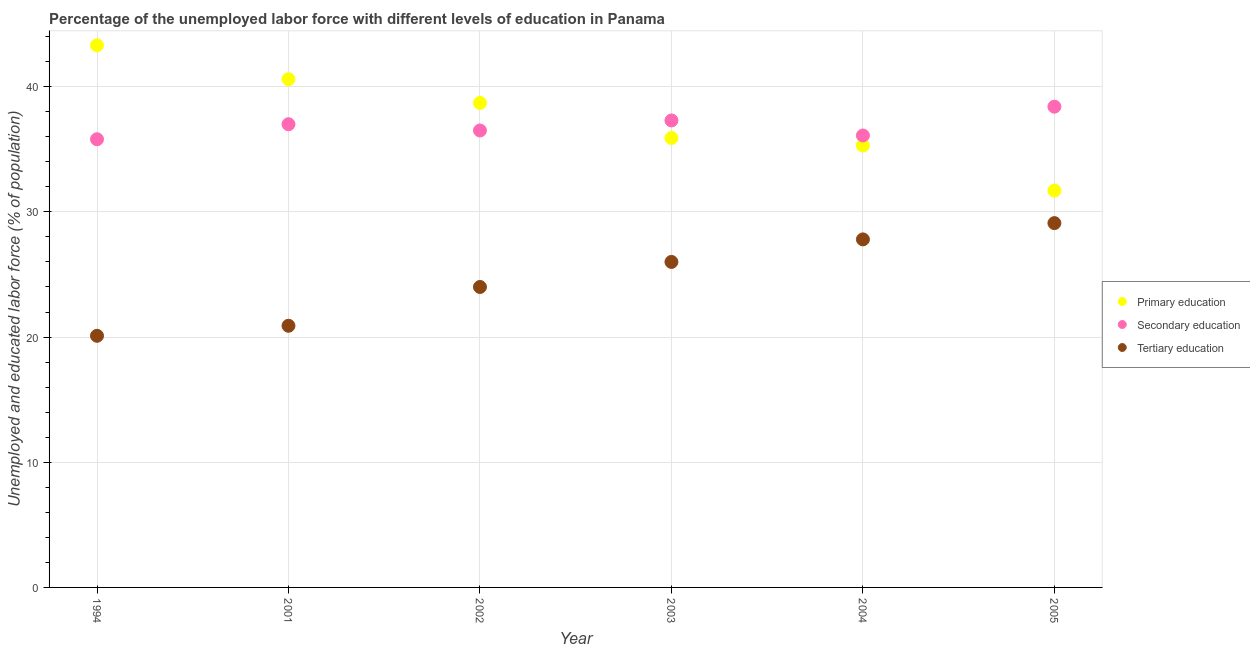How many different coloured dotlines are there?
Your answer should be very brief. 3. What is the percentage of labor force who received secondary education in 2003?
Give a very brief answer. 37.3. Across all years, what is the maximum percentage of labor force who received primary education?
Give a very brief answer. 43.3. Across all years, what is the minimum percentage of labor force who received primary education?
Provide a succinct answer. 31.7. What is the total percentage of labor force who received secondary education in the graph?
Provide a succinct answer. 221.1. What is the difference between the percentage of labor force who received primary education in 2003 and that in 2004?
Give a very brief answer. 0.6. What is the difference between the percentage of labor force who received tertiary education in 2003 and the percentage of labor force who received secondary education in 2005?
Give a very brief answer. -12.4. What is the average percentage of labor force who received primary education per year?
Ensure brevity in your answer.  37.58. In the year 2005, what is the difference between the percentage of labor force who received tertiary education and percentage of labor force who received primary education?
Keep it short and to the point. -2.6. In how many years, is the percentage of labor force who received primary education greater than 42 %?
Give a very brief answer. 1. What is the ratio of the percentage of labor force who received secondary education in 2001 to that in 2005?
Offer a very short reply. 0.96. Is the difference between the percentage of labor force who received primary education in 1994 and 2003 greater than the difference between the percentage of labor force who received tertiary education in 1994 and 2003?
Your answer should be very brief. Yes. What is the difference between the highest and the second highest percentage of labor force who received primary education?
Make the answer very short. 2.7. What is the difference between the highest and the lowest percentage of labor force who received primary education?
Provide a short and direct response. 11.6. In how many years, is the percentage of labor force who received primary education greater than the average percentage of labor force who received primary education taken over all years?
Ensure brevity in your answer.  3. Is it the case that in every year, the sum of the percentage of labor force who received primary education and percentage of labor force who received secondary education is greater than the percentage of labor force who received tertiary education?
Offer a very short reply. Yes. How many dotlines are there?
Your answer should be compact. 3. How many years are there in the graph?
Offer a very short reply. 6. What is the difference between two consecutive major ticks on the Y-axis?
Offer a very short reply. 10. Does the graph contain any zero values?
Make the answer very short. No. Does the graph contain grids?
Give a very brief answer. Yes. Where does the legend appear in the graph?
Provide a short and direct response. Center right. How are the legend labels stacked?
Offer a terse response. Vertical. What is the title of the graph?
Provide a succinct answer. Percentage of the unemployed labor force with different levels of education in Panama. What is the label or title of the X-axis?
Your answer should be compact. Year. What is the label or title of the Y-axis?
Your answer should be compact. Unemployed and educated labor force (% of population). What is the Unemployed and educated labor force (% of population) of Primary education in 1994?
Ensure brevity in your answer.  43.3. What is the Unemployed and educated labor force (% of population) of Secondary education in 1994?
Provide a succinct answer. 35.8. What is the Unemployed and educated labor force (% of population) of Tertiary education in 1994?
Your answer should be very brief. 20.1. What is the Unemployed and educated labor force (% of population) of Primary education in 2001?
Offer a very short reply. 40.6. What is the Unemployed and educated labor force (% of population) of Secondary education in 2001?
Offer a terse response. 37. What is the Unemployed and educated labor force (% of population) in Tertiary education in 2001?
Provide a succinct answer. 20.9. What is the Unemployed and educated labor force (% of population) of Primary education in 2002?
Make the answer very short. 38.7. What is the Unemployed and educated labor force (% of population) in Secondary education in 2002?
Offer a terse response. 36.5. What is the Unemployed and educated labor force (% of population) in Primary education in 2003?
Make the answer very short. 35.9. What is the Unemployed and educated labor force (% of population) of Secondary education in 2003?
Your answer should be compact. 37.3. What is the Unemployed and educated labor force (% of population) in Primary education in 2004?
Provide a short and direct response. 35.3. What is the Unemployed and educated labor force (% of population) in Secondary education in 2004?
Provide a short and direct response. 36.1. What is the Unemployed and educated labor force (% of population) of Tertiary education in 2004?
Provide a short and direct response. 27.8. What is the Unemployed and educated labor force (% of population) in Primary education in 2005?
Offer a very short reply. 31.7. What is the Unemployed and educated labor force (% of population) of Secondary education in 2005?
Ensure brevity in your answer.  38.4. What is the Unemployed and educated labor force (% of population) in Tertiary education in 2005?
Your response must be concise. 29.1. Across all years, what is the maximum Unemployed and educated labor force (% of population) of Primary education?
Provide a short and direct response. 43.3. Across all years, what is the maximum Unemployed and educated labor force (% of population) in Secondary education?
Ensure brevity in your answer.  38.4. Across all years, what is the maximum Unemployed and educated labor force (% of population) in Tertiary education?
Your response must be concise. 29.1. Across all years, what is the minimum Unemployed and educated labor force (% of population) in Primary education?
Offer a very short reply. 31.7. Across all years, what is the minimum Unemployed and educated labor force (% of population) of Secondary education?
Provide a short and direct response. 35.8. Across all years, what is the minimum Unemployed and educated labor force (% of population) in Tertiary education?
Ensure brevity in your answer.  20.1. What is the total Unemployed and educated labor force (% of population) of Primary education in the graph?
Your answer should be compact. 225.5. What is the total Unemployed and educated labor force (% of population) in Secondary education in the graph?
Provide a succinct answer. 221.1. What is the total Unemployed and educated labor force (% of population) of Tertiary education in the graph?
Provide a short and direct response. 147.9. What is the difference between the Unemployed and educated labor force (% of population) of Primary education in 1994 and that in 2001?
Keep it short and to the point. 2.7. What is the difference between the Unemployed and educated labor force (% of population) in Secondary education in 1994 and that in 2001?
Your response must be concise. -1.2. What is the difference between the Unemployed and educated labor force (% of population) of Tertiary education in 1994 and that in 2001?
Your response must be concise. -0.8. What is the difference between the Unemployed and educated labor force (% of population) of Tertiary education in 1994 and that in 2002?
Your answer should be very brief. -3.9. What is the difference between the Unemployed and educated labor force (% of population) of Primary education in 1994 and that in 2004?
Provide a short and direct response. 8. What is the difference between the Unemployed and educated labor force (% of population) of Secondary education in 1994 and that in 2004?
Offer a terse response. -0.3. What is the difference between the Unemployed and educated labor force (% of population) in Tertiary education in 1994 and that in 2004?
Provide a succinct answer. -7.7. What is the difference between the Unemployed and educated labor force (% of population) of Primary education in 1994 and that in 2005?
Ensure brevity in your answer.  11.6. What is the difference between the Unemployed and educated labor force (% of population) in Secondary education in 2001 and that in 2002?
Keep it short and to the point. 0.5. What is the difference between the Unemployed and educated labor force (% of population) of Tertiary education in 2001 and that in 2002?
Offer a terse response. -3.1. What is the difference between the Unemployed and educated labor force (% of population) in Primary education in 2001 and that in 2003?
Keep it short and to the point. 4.7. What is the difference between the Unemployed and educated labor force (% of population) of Secondary education in 2001 and that in 2003?
Your response must be concise. -0.3. What is the difference between the Unemployed and educated labor force (% of population) of Secondary education in 2001 and that in 2004?
Keep it short and to the point. 0.9. What is the difference between the Unemployed and educated labor force (% of population) of Tertiary education in 2001 and that in 2004?
Provide a succinct answer. -6.9. What is the difference between the Unemployed and educated labor force (% of population) in Primary education in 2001 and that in 2005?
Ensure brevity in your answer.  8.9. What is the difference between the Unemployed and educated labor force (% of population) of Primary education in 2002 and that in 2003?
Provide a succinct answer. 2.8. What is the difference between the Unemployed and educated labor force (% of population) in Secondary education in 2002 and that in 2003?
Provide a succinct answer. -0.8. What is the difference between the Unemployed and educated labor force (% of population) of Tertiary education in 2002 and that in 2003?
Make the answer very short. -2. What is the difference between the Unemployed and educated labor force (% of population) of Primary education in 2002 and that in 2004?
Make the answer very short. 3.4. What is the difference between the Unemployed and educated labor force (% of population) in Secondary education in 2002 and that in 2004?
Your answer should be very brief. 0.4. What is the difference between the Unemployed and educated labor force (% of population) of Tertiary education in 2002 and that in 2004?
Give a very brief answer. -3.8. What is the difference between the Unemployed and educated labor force (% of population) in Primary education in 2002 and that in 2005?
Provide a short and direct response. 7. What is the difference between the Unemployed and educated labor force (% of population) in Primary education in 2003 and that in 2005?
Provide a succinct answer. 4.2. What is the difference between the Unemployed and educated labor force (% of population) of Tertiary education in 2003 and that in 2005?
Provide a short and direct response. -3.1. What is the difference between the Unemployed and educated labor force (% of population) in Primary education in 2004 and that in 2005?
Offer a terse response. 3.6. What is the difference between the Unemployed and educated labor force (% of population) in Secondary education in 2004 and that in 2005?
Make the answer very short. -2.3. What is the difference between the Unemployed and educated labor force (% of population) in Primary education in 1994 and the Unemployed and educated labor force (% of population) in Tertiary education in 2001?
Provide a succinct answer. 22.4. What is the difference between the Unemployed and educated labor force (% of population) in Primary education in 1994 and the Unemployed and educated labor force (% of population) in Tertiary education in 2002?
Ensure brevity in your answer.  19.3. What is the difference between the Unemployed and educated labor force (% of population) in Secondary education in 1994 and the Unemployed and educated labor force (% of population) in Tertiary education in 2002?
Provide a succinct answer. 11.8. What is the difference between the Unemployed and educated labor force (% of population) of Primary education in 1994 and the Unemployed and educated labor force (% of population) of Tertiary education in 2003?
Your response must be concise. 17.3. What is the difference between the Unemployed and educated labor force (% of population) of Primary education in 1994 and the Unemployed and educated labor force (% of population) of Tertiary education in 2004?
Provide a succinct answer. 15.5. What is the difference between the Unemployed and educated labor force (% of population) in Primary education in 1994 and the Unemployed and educated labor force (% of population) in Tertiary education in 2005?
Your answer should be very brief. 14.2. What is the difference between the Unemployed and educated labor force (% of population) in Secondary education in 2001 and the Unemployed and educated labor force (% of population) in Tertiary education in 2002?
Provide a succinct answer. 13. What is the difference between the Unemployed and educated labor force (% of population) in Primary education in 2001 and the Unemployed and educated labor force (% of population) in Secondary education in 2003?
Provide a short and direct response. 3.3. What is the difference between the Unemployed and educated labor force (% of population) of Primary education in 2001 and the Unemployed and educated labor force (% of population) of Tertiary education in 2003?
Give a very brief answer. 14.6. What is the difference between the Unemployed and educated labor force (% of population) of Secondary education in 2001 and the Unemployed and educated labor force (% of population) of Tertiary education in 2003?
Provide a short and direct response. 11. What is the difference between the Unemployed and educated labor force (% of population) of Secondary education in 2001 and the Unemployed and educated labor force (% of population) of Tertiary education in 2004?
Your answer should be compact. 9.2. What is the difference between the Unemployed and educated labor force (% of population) in Primary education in 2001 and the Unemployed and educated labor force (% of population) in Tertiary education in 2005?
Your answer should be very brief. 11.5. What is the difference between the Unemployed and educated labor force (% of population) of Primary education in 2002 and the Unemployed and educated labor force (% of population) of Secondary education in 2003?
Provide a short and direct response. 1.4. What is the difference between the Unemployed and educated labor force (% of population) of Primary education in 2002 and the Unemployed and educated labor force (% of population) of Tertiary education in 2003?
Your answer should be very brief. 12.7. What is the difference between the Unemployed and educated labor force (% of population) in Secondary education in 2002 and the Unemployed and educated labor force (% of population) in Tertiary education in 2003?
Your answer should be very brief. 10.5. What is the difference between the Unemployed and educated labor force (% of population) in Primary education in 2002 and the Unemployed and educated labor force (% of population) in Tertiary education in 2004?
Your answer should be compact. 10.9. What is the difference between the Unemployed and educated labor force (% of population) in Primary education in 2002 and the Unemployed and educated labor force (% of population) in Tertiary education in 2005?
Ensure brevity in your answer.  9.6. What is the difference between the Unemployed and educated labor force (% of population) of Secondary education in 2002 and the Unemployed and educated labor force (% of population) of Tertiary education in 2005?
Ensure brevity in your answer.  7.4. What is the difference between the Unemployed and educated labor force (% of population) in Primary education in 2003 and the Unemployed and educated labor force (% of population) in Tertiary education in 2004?
Your answer should be very brief. 8.1. What is the difference between the Unemployed and educated labor force (% of population) of Primary education in 2003 and the Unemployed and educated labor force (% of population) of Tertiary education in 2005?
Offer a terse response. 6.8. What is the average Unemployed and educated labor force (% of population) of Primary education per year?
Offer a terse response. 37.58. What is the average Unemployed and educated labor force (% of population) of Secondary education per year?
Your response must be concise. 36.85. What is the average Unemployed and educated labor force (% of population) in Tertiary education per year?
Make the answer very short. 24.65. In the year 1994, what is the difference between the Unemployed and educated labor force (% of population) of Primary education and Unemployed and educated labor force (% of population) of Tertiary education?
Provide a short and direct response. 23.2. In the year 1994, what is the difference between the Unemployed and educated labor force (% of population) of Secondary education and Unemployed and educated labor force (% of population) of Tertiary education?
Your answer should be very brief. 15.7. In the year 2001, what is the difference between the Unemployed and educated labor force (% of population) in Primary education and Unemployed and educated labor force (% of population) in Tertiary education?
Offer a terse response. 19.7. In the year 2002, what is the difference between the Unemployed and educated labor force (% of population) of Primary education and Unemployed and educated labor force (% of population) of Tertiary education?
Provide a short and direct response. 14.7. In the year 2003, what is the difference between the Unemployed and educated labor force (% of population) in Primary education and Unemployed and educated labor force (% of population) in Secondary education?
Give a very brief answer. -1.4. In the year 2003, what is the difference between the Unemployed and educated labor force (% of population) of Primary education and Unemployed and educated labor force (% of population) of Tertiary education?
Keep it short and to the point. 9.9. In the year 2004, what is the difference between the Unemployed and educated labor force (% of population) in Primary education and Unemployed and educated labor force (% of population) in Secondary education?
Your answer should be very brief. -0.8. In the year 2004, what is the difference between the Unemployed and educated labor force (% of population) of Primary education and Unemployed and educated labor force (% of population) of Tertiary education?
Provide a short and direct response. 7.5. In the year 2004, what is the difference between the Unemployed and educated labor force (% of population) of Secondary education and Unemployed and educated labor force (% of population) of Tertiary education?
Make the answer very short. 8.3. In the year 2005, what is the difference between the Unemployed and educated labor force (% of population) in Primary education and Unemployed and educated labor force (% of population) in Secondary education?
Your response must be concise. -6.7. In the year 2005, what is the difference between the Unemployed and educated labor force (% of population) of Secondary education and Unemployed and educated labor force (% of population) of Tertiary education?
Offer a terse response. 9.3. What is the ratio of the Unemployed and educated labor force (% of population) in Primary education in 1994 to that in 2001?
Make the answer very short. 1.07. What is the ratio of the Unemployed and educated labor force (% of population) in Secondary education in 1994 to that in 2001?
Provide a succinct answer. 0.97. What is the ratio of the Unemployed and educated labor force (% of population) of Tertiary education in 1994 to that in 2001?
Provide a short and direct response. 0.96. What is the ratio of the Unemployed and educated labor force (% of population) of Primary education in 1994 to that in 2002?
Your answer should be compact. 1.12. What is the ratio of the Unemployed and educated labor force (% of population) in Secondary education in 1994 to that in 2002?
Your response must be concise. 0.98. What is the ratio of the Unemployed and educated labor force (% of population) in Tertiary education in 1994 to that in 2002?
Provide a short and direct response. 0.84. What is the ratio of the Unemployed and educated labor force (% of population) of Primary education in 1994 to that in 2003?
Provide a succinct answer. 1.21. What is the ratio of the Unemployed and educated labor force (% of population) of Secondary education in 1994 to that in 2003?
Ensure brevity in your answer.  0.96. What is the ratio of the Unemployed and educated labor force (% of population) of Tertiary education in 1994 to that in 2003?
Provide a short and direct response. 0.77. What is the ratio of the Unemployed and educated labor force (% of population) in Primary education in 1994 to that in 2004?
Your answer should be very brief. 1.23. What is the ratio of the Unemployed and educated labor force (% of population) of Tertiary education in 1994 to that in 2004?
Give a very brief answer. 0.72. What is the ratio of the Unemployed and educated labor force (% of population) in Primary education in 1994 to that in 2005?
Your response must be concise. 1.37. What is the ratio of the Unemployed and educated labor force (% of population) in Secondary education in 1994 to that in 2005?
Make the answer very short. 0.93. What is the ratio of the Unemployed and educated labor force (% of population) of Tertiary education in 1994 to that in 2005?
Offer a terse response. 0.69. What is the ratio of the Unemployed and educated labor force (% of population) in Primary education in 2001 to that in 2002?
Ensure brevity in your answer.  1.05. What is the ratio of the Unemployed and educated labor force (% of population) of Secondary education in 2001 to that in 2002?
Your answer should be very brief. 1.01. What is the ratio of the Unemployed and educated labor force (% of population) of Tertiary education in 2001 to that in 2002?
Provide a short and direct response. 0.87. What is the ratio of the Unemployed and educated labor force (% of population) of Primary education in 2001 to that in 2003?
Make the answer very short. 1.13. What is the ratio of the Unemployed and educated labor force (% of population) in Tertiary education in 2001 to that in 2003?
Offer a terse response. 0.8. What is the ratio of the Unemployed and educated labor force (% of population) of Primary education in 2001 to that in 2004?
Provide a succinct answer. 1.15. What is the ratio of the Unemployed and educated labor force (% of population) in Secondary education in 2001 to that in 2004?
Provide a succinct answer. 1.02. What is the ratio of the Unemployed and educated labor force (% of population) in Tertiary education in 2001 to that in 2004?
Offer a terse response. 0.75. What is the ratio of the Unemployed and educated labor force (% of population) in Primary education in 2001 to that in 2005?
Your response must be concise. 1.28. What is the ratio of the Unemployed and educated labor force (% of population) in Secondary education in 2001 to that in 2005?
Keep it short and to the point. 0.96. What is the ratio of the Unemployed and educated labor force (% of population) of Tertiary education in 2001 to that in 2005?
Your answer should be very brief. 0.72. What is the ratio of the Unemployed and educated labor force (% of population) of Primary education in 2002 to that in 2003?
Your response must be concise. 1.08. What is the ratio of the Unemployed and educated labor force (% of population) of Secondary education in 2002 to that in 2003?
Make the answer very short. 0.98. What is the ratio of the Unemployed and educated labor force (% of population) of Primary education in 2002 to that in 2004?
Provide a short and direct response. 1.1. What is the ratio of the Unemployed and educated labor force (% of population) in Secondary education in 2002 to that in 2004?
Make the answer very short. 1.01. What is the ratio of the Unemployed and educated labor force (% of population) of Tertiary education in 2002 to that in 2004?
Give a very brief answer. 0.86. What is the ratio of the Unemployed and educated labor force (% of population) in Primary education in 2002 to that in 2005?
Keep it short and to the point. 1.22. What is the ratio of the Unemployed and educated labor force (% of population) in Secondary education in 2002 to that in 2005?
Provide a short and direct response. 0.95. What is the ratio of the Unemployed and educated labor force (% of population) of Tertiary education in 2002 to that in 2005?
Provide a short and direct response. 0.82. What is the ratio of the Unemployed and educated labor force (% of population) of Secondary education in 2003 to that in 2004?
Ensure brevity in your answer.  1.03. What is the ratio of the Unemployed and educated labor force (% of population) in Tertiary education in 2003 to that in 2004?
Give a very brief answer. 0.94. What is the ratio of the Unemployed and educated labor force (% of population) of Primary education in 2003 to that in 2005?
Give a very brief answer. 1.13. What is the ratio of the Unemployed and educated labor force (% of population) of Secondary education in 2003 to that in 2005?
Offer a very short reply. 0.97. What is the ratio of the Unemployed and educated labor force (% of population) of Tertiary education in 2003 to that in 2005?
Keep it short and to the point. 0.89. What is the ratio of the Unemployed and educated labor force (% of population) of Primary education in 2004 to that in 2005?
Your answer should be very brief. 1.11. What is the ratio of the Unemployed and educated labor force (% of population) in Secondary education in 2004 to that in 2005?
Give a very brief answer. 0.94. What is the ratio of the Unemployed and educated labor force (% of population) in Tertiary education in 2004 to that in 2005?
Provide a succinct answer. 0.96. What is the difference between the highest and the lowest Unemployed and educated labor force (% of population) in Secondary education?
Your response must be concise. 2.6. 